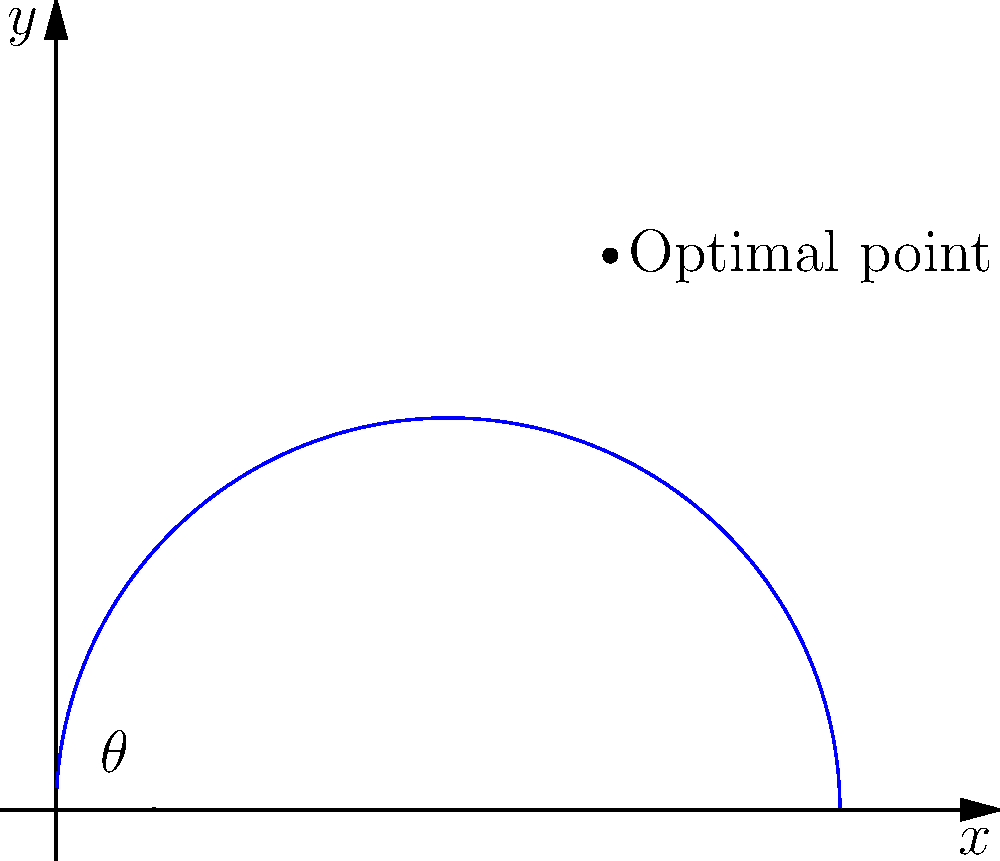In a crucial match, Léo Laurent is preparing for a conversion kick. The optimal point for the kick can be described using polar coordinates, where the distance from the goal post is given by the function $r(\theta) = 40\cos(\theta)$, with $\theta$ measured in radians from the x-axis. At what angle $\theta$ should Léo aim to maximize his chances of a successful conversion? To find the optimal angle for the kick, we need to maximize the value of $r(\theta)$. Let's approach this step-by-step:

1) The given function is $r(\theta) = 40\cos(\theta)$

2) To find the maximum value, we need to differentiate $r(\theta)$ with respect to $\theta$ and set it to zero:

   $$\frac{dr}{d\theta} = -40\sin(\theta)$$

3) Setting this equal to zero:
   
   $$-40\sin(\theta) = 0$$
   $$\sin(\theta) = 0$$

4) The solutions to this equation in the range $[0, \pi/2]$ (as the kick is in the first quadrant) are:

   $$\theta = 0$$

5) To confirm this is a maximum (not a minimum), we can check the second derivative:

   $$\frac{d^2r}{d\theta^2} = -40\cos(\theta)$$

   At $\theta = 0$, this is negative, confirming a maximum.

6) Therefore, the optimal angle for the kick is when $\theta = 0$ radians, or directly along the x-axis.

This makes intuitive sense, as the closest point to the goal post (and thus the easiest kick) would be directly in front of it.
Answer: $0$ radians 